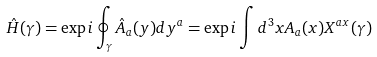Convert formula to latex. <formula><loc_0><loc_0><loc_500><loc_500>{ \hat { H } } ( \gamma ) = \exp { i \oint _ { \gamma } { \hat { A } } _ { a } ( y ) d y ^ { a } } = \exp { i \int d ^ { 3 } x A _ { a } ( x ) X ^ { a x } ( \gamma ) }</formula> 